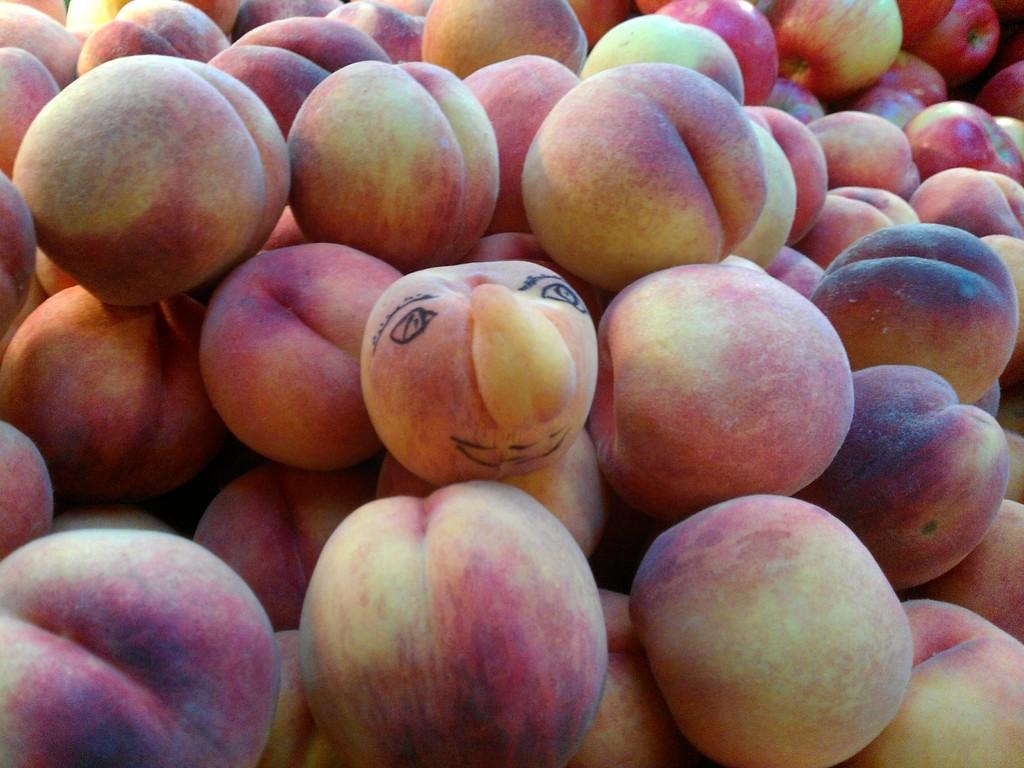What type of fruit is visible in the image? There is a group of apples in the image. How many apples are in the group? The number of apples in the group cannot be determined from the image alone. What color are the apples? The color of the apples cannot be determined from the image alone. Are the apples arranged in any particular pattern? The arrangement of the apples cannot be determined from the image alone. What type of comfort can be seen in the image? There is no reference to comfort in the image, as it features a group of apples. 